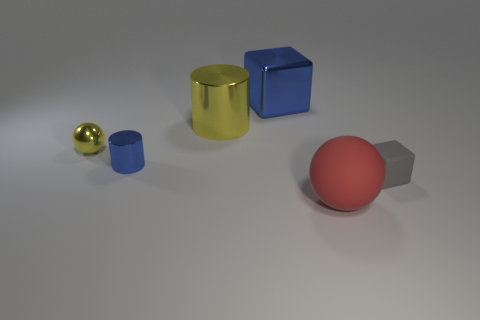Which objects in the image are metallic? The objects that appear metallic in the image are the yellow cylinder and the small golden sphere. 